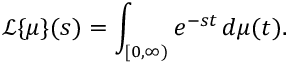<formula> <loc_0><loc_0><loc_500><loc_500>{ \mathcal { L } } \{ \mu \} ( s ) = \int _ { [ 0 , \infty ) } e ^ { - s t } \, d \mu ( t ) .</formula> 